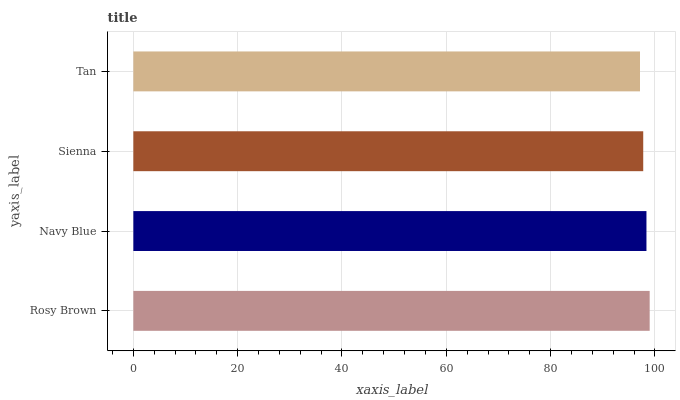Is Tan the minimum?
Answer yes or no. Yes. Is Rosy Brown the maximum?
Answer yes or no. Yes. Is Navy Blue the minimum?
Answer yes or no. No. Is Navy Blue the maximum?
Answer yes or no. No. Is Rosy Brown greater than Navy Blue?
Answer yes or no. Yes. Is Navy Blue less than Rosy Brown?
Answer yes or no. Yes. Is Navy Blue greater than Rosy Brown?
Answer yes or no. No. Is Rosy Brown less than Navy Blue?
Answer yes or no. No. Is Navy Blue the high median?
Answer yes or no. Yes. Is Sienna the low median?
Answer yes or no. Yes. Is Sienna the high median?
Answer yes or no. No. Is Rosy Brown the low median?
Answer yes or no. No. 